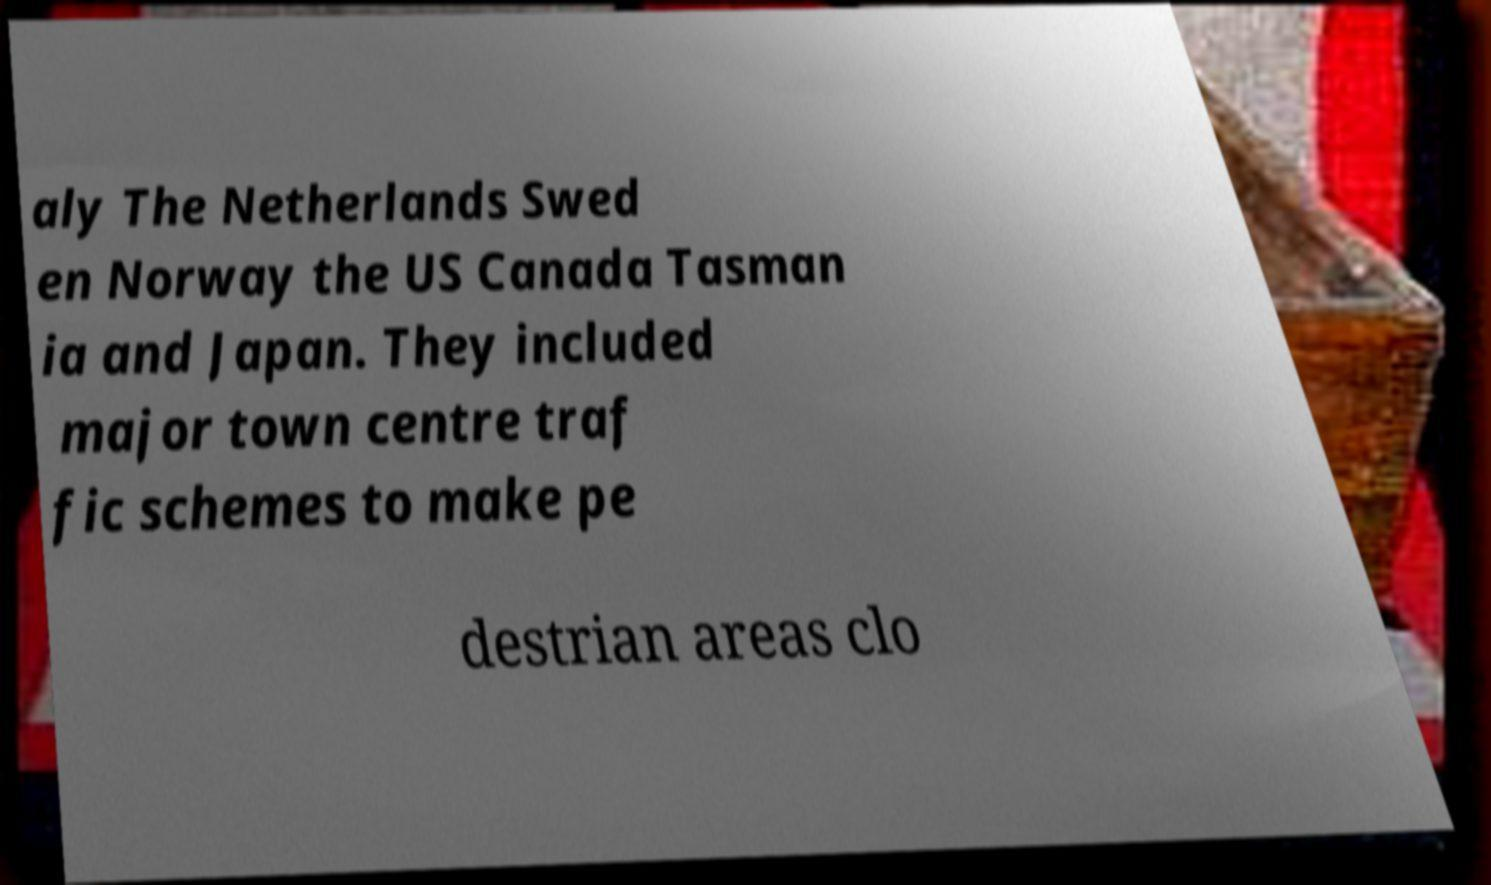Can you read and provide the text displayed in the image?This photo seems to have some interesting text. Can you extract and type it out for me? aly The Netherlands Swed en Norway the US Canada Tasman ia and Japan. They included major town centre traf fic schemes to make pe destrian areas clo 